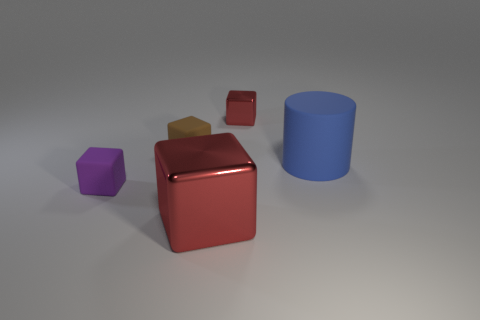Add 3 matte objects. How many objects exist? 8 Subtract all cylinders. How many objects are left? 4 Add 2 small red blocks. How many small red blocks are left? 3 Add 5 tiny brown blocks. How many tiny brown blocks exist? 6 Subtract 0 cyan balls. How many objects are left? 5 Subtract all gray cylinders. Subtract all large blue rubber cylinders. How many objects are left? 4 